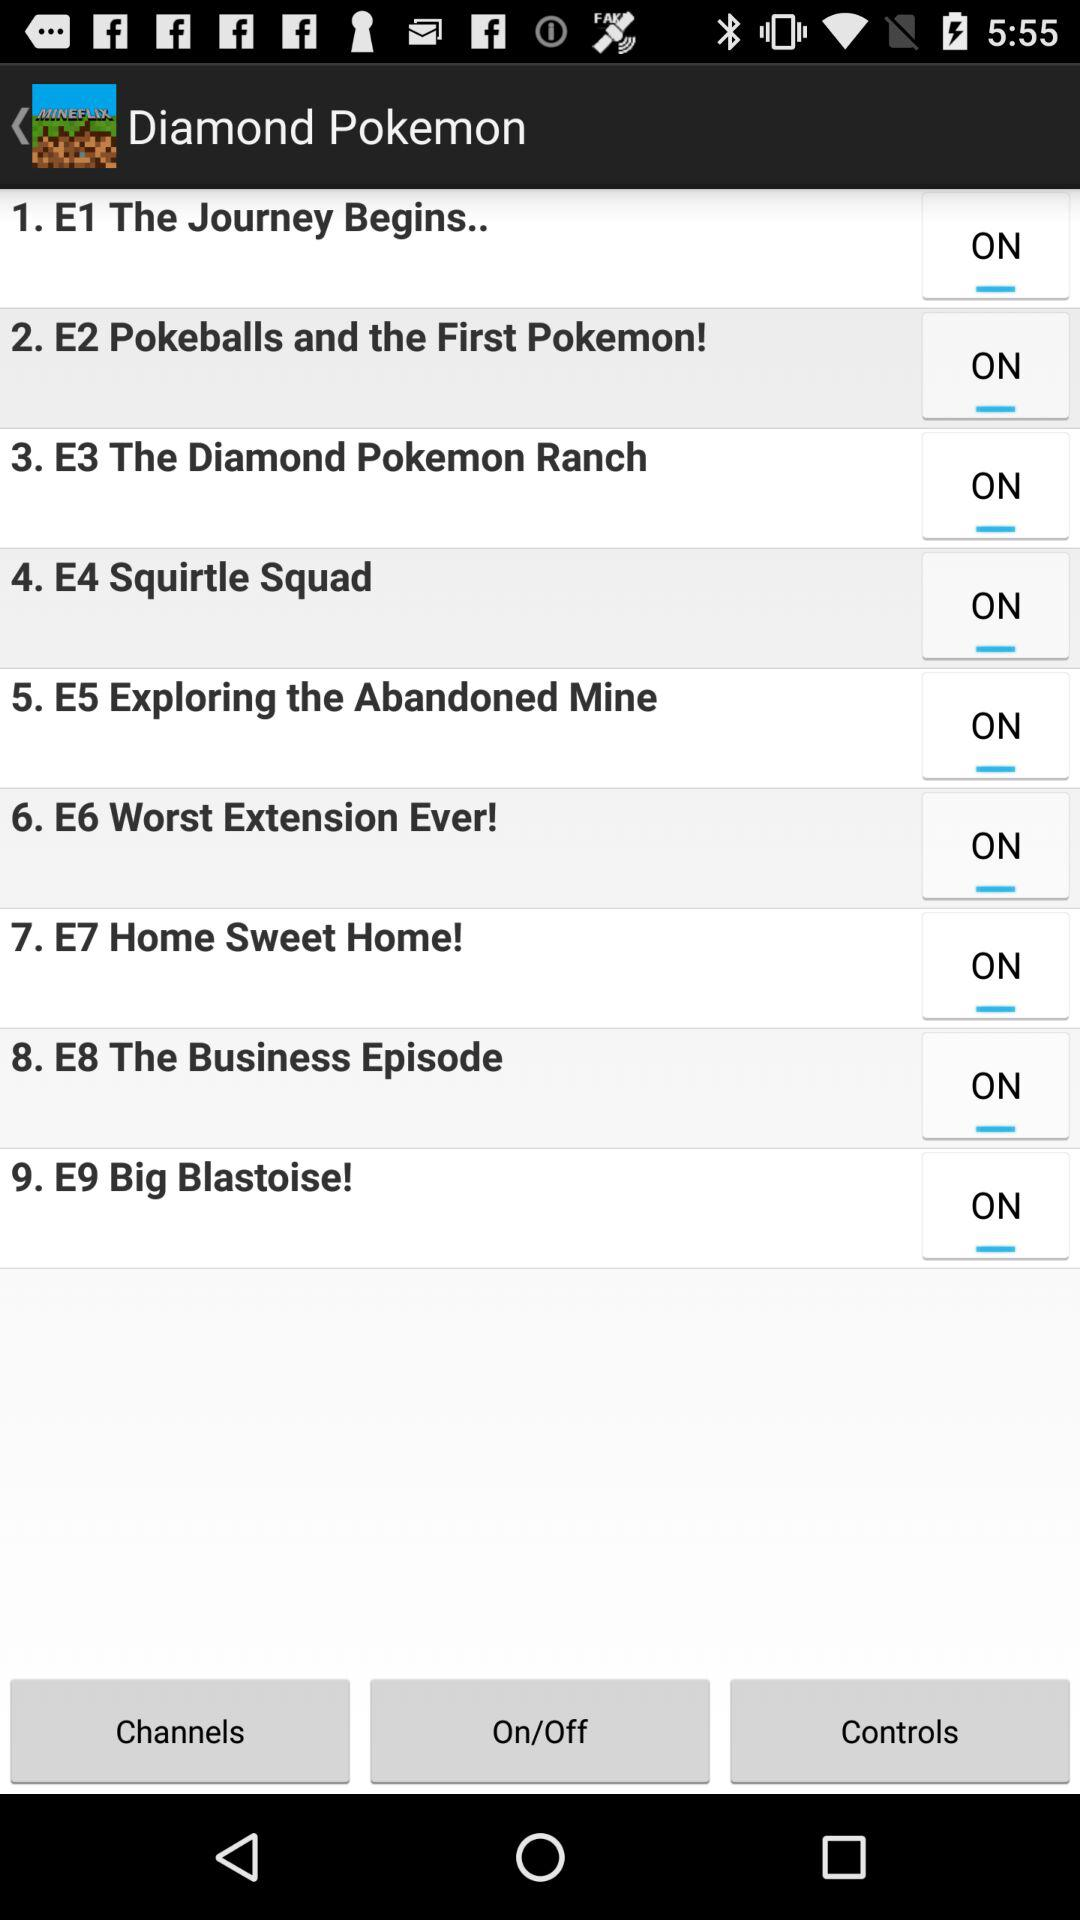What is the name of episode 4? The name of episode 4 is "Squirtle Squad". 